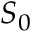<formula> <loc_0><loc_0><loc_500><loc_500>S _ { 0 }</formula> 